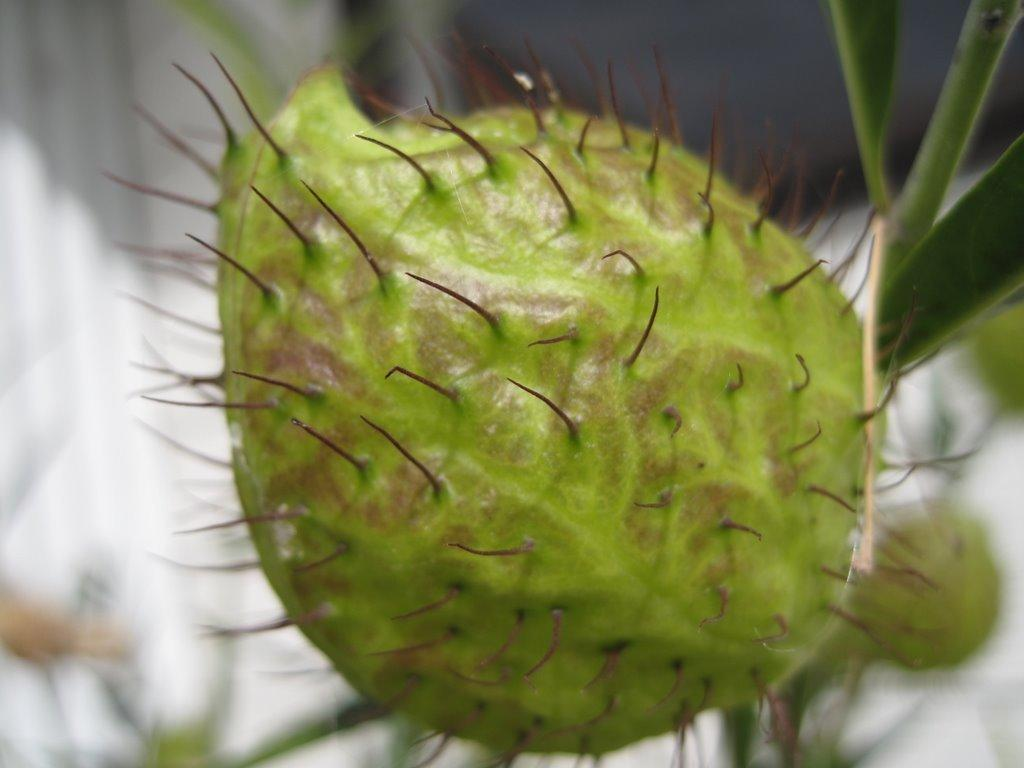What is the main subject of the image? The main subject of the image is a bud. What color is the bud in the image? The bud is green. What else can be seen in the image besides the bud? There are leaves in the image. What color are the leaves in the image? The leaves are green. What color is the background of the image? The background of the image is white. Can you tell me which actor is featured in the store in the image? There is no actor or store present in the image; it features a green bud and leaves against a white background. 